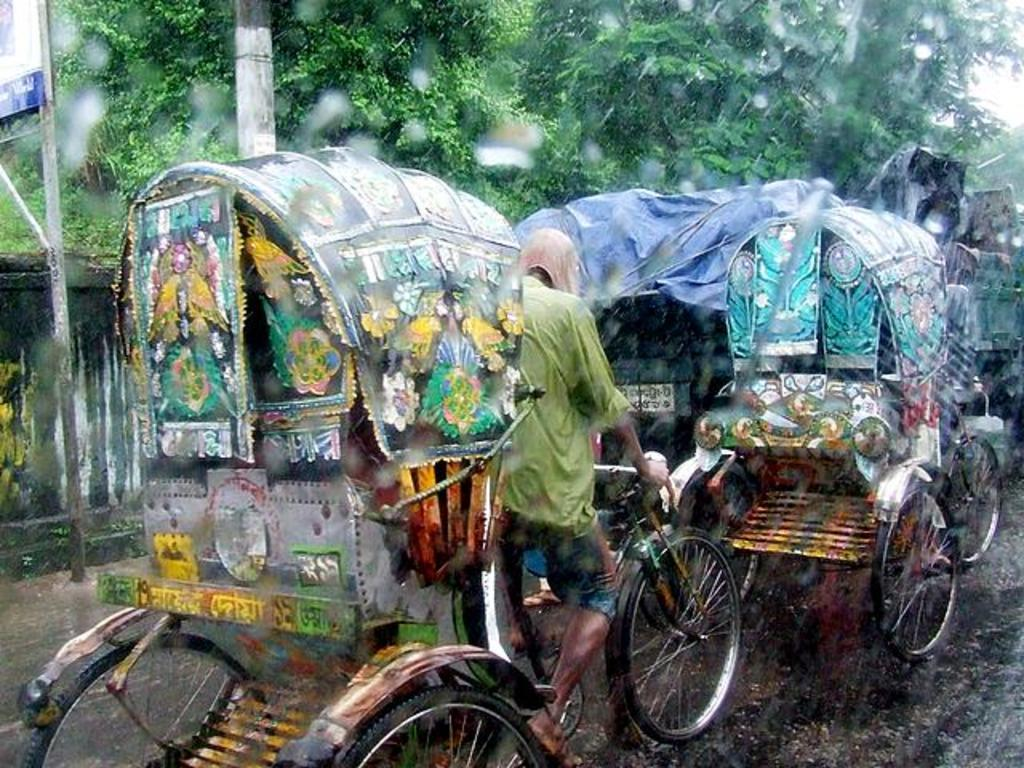What can be seen on the road in the image? There are rashes on the road in the image. What is visible in the background of the image? There are trees in the background of the image. What is the weather like in the image? It is raining in the image. Where is the train located in the image? There is no train present in the image. What type of scissors can be seen cutting the rashes on the road? There are no scissors present in the image, and the rashes are not being cut. 